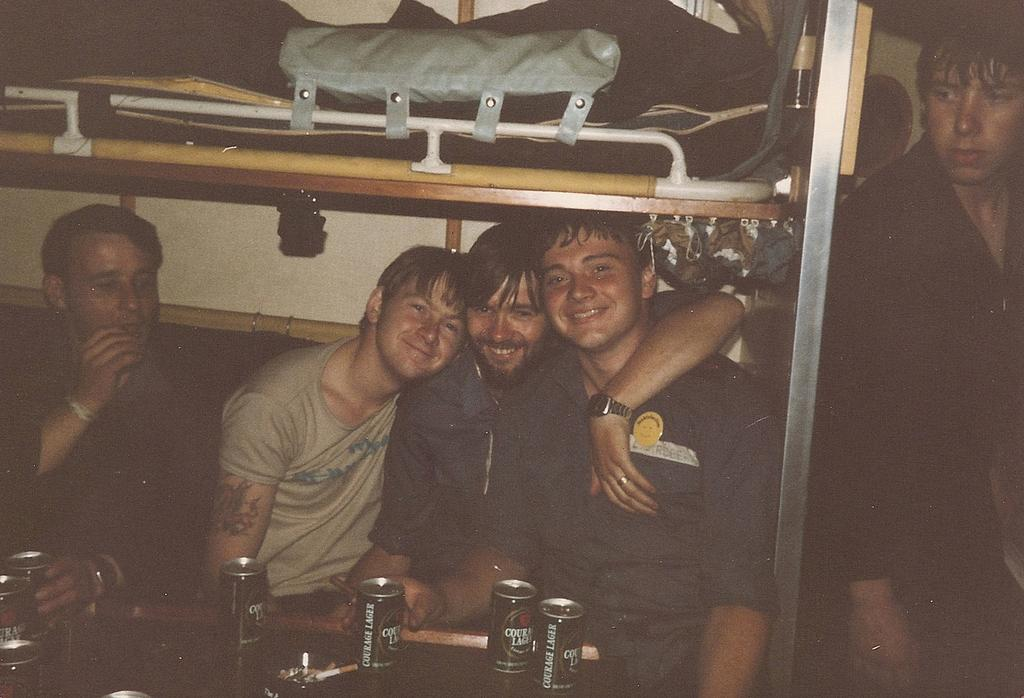How many people are in the image? There are four persons in the image. What is the facial expression of the people in the image? The persons are smiling. What objects are in front of the persons? There are cock tins in front of the persons. What is located at the top of the image? There is a bed at the top of the image. Where is the person positioned in the image? There is a person on the left side of the image. What note is the person on the left side of the image playing on the bed? There is no indication of a musical note or instrument in the image, and the person is not on the bed. 